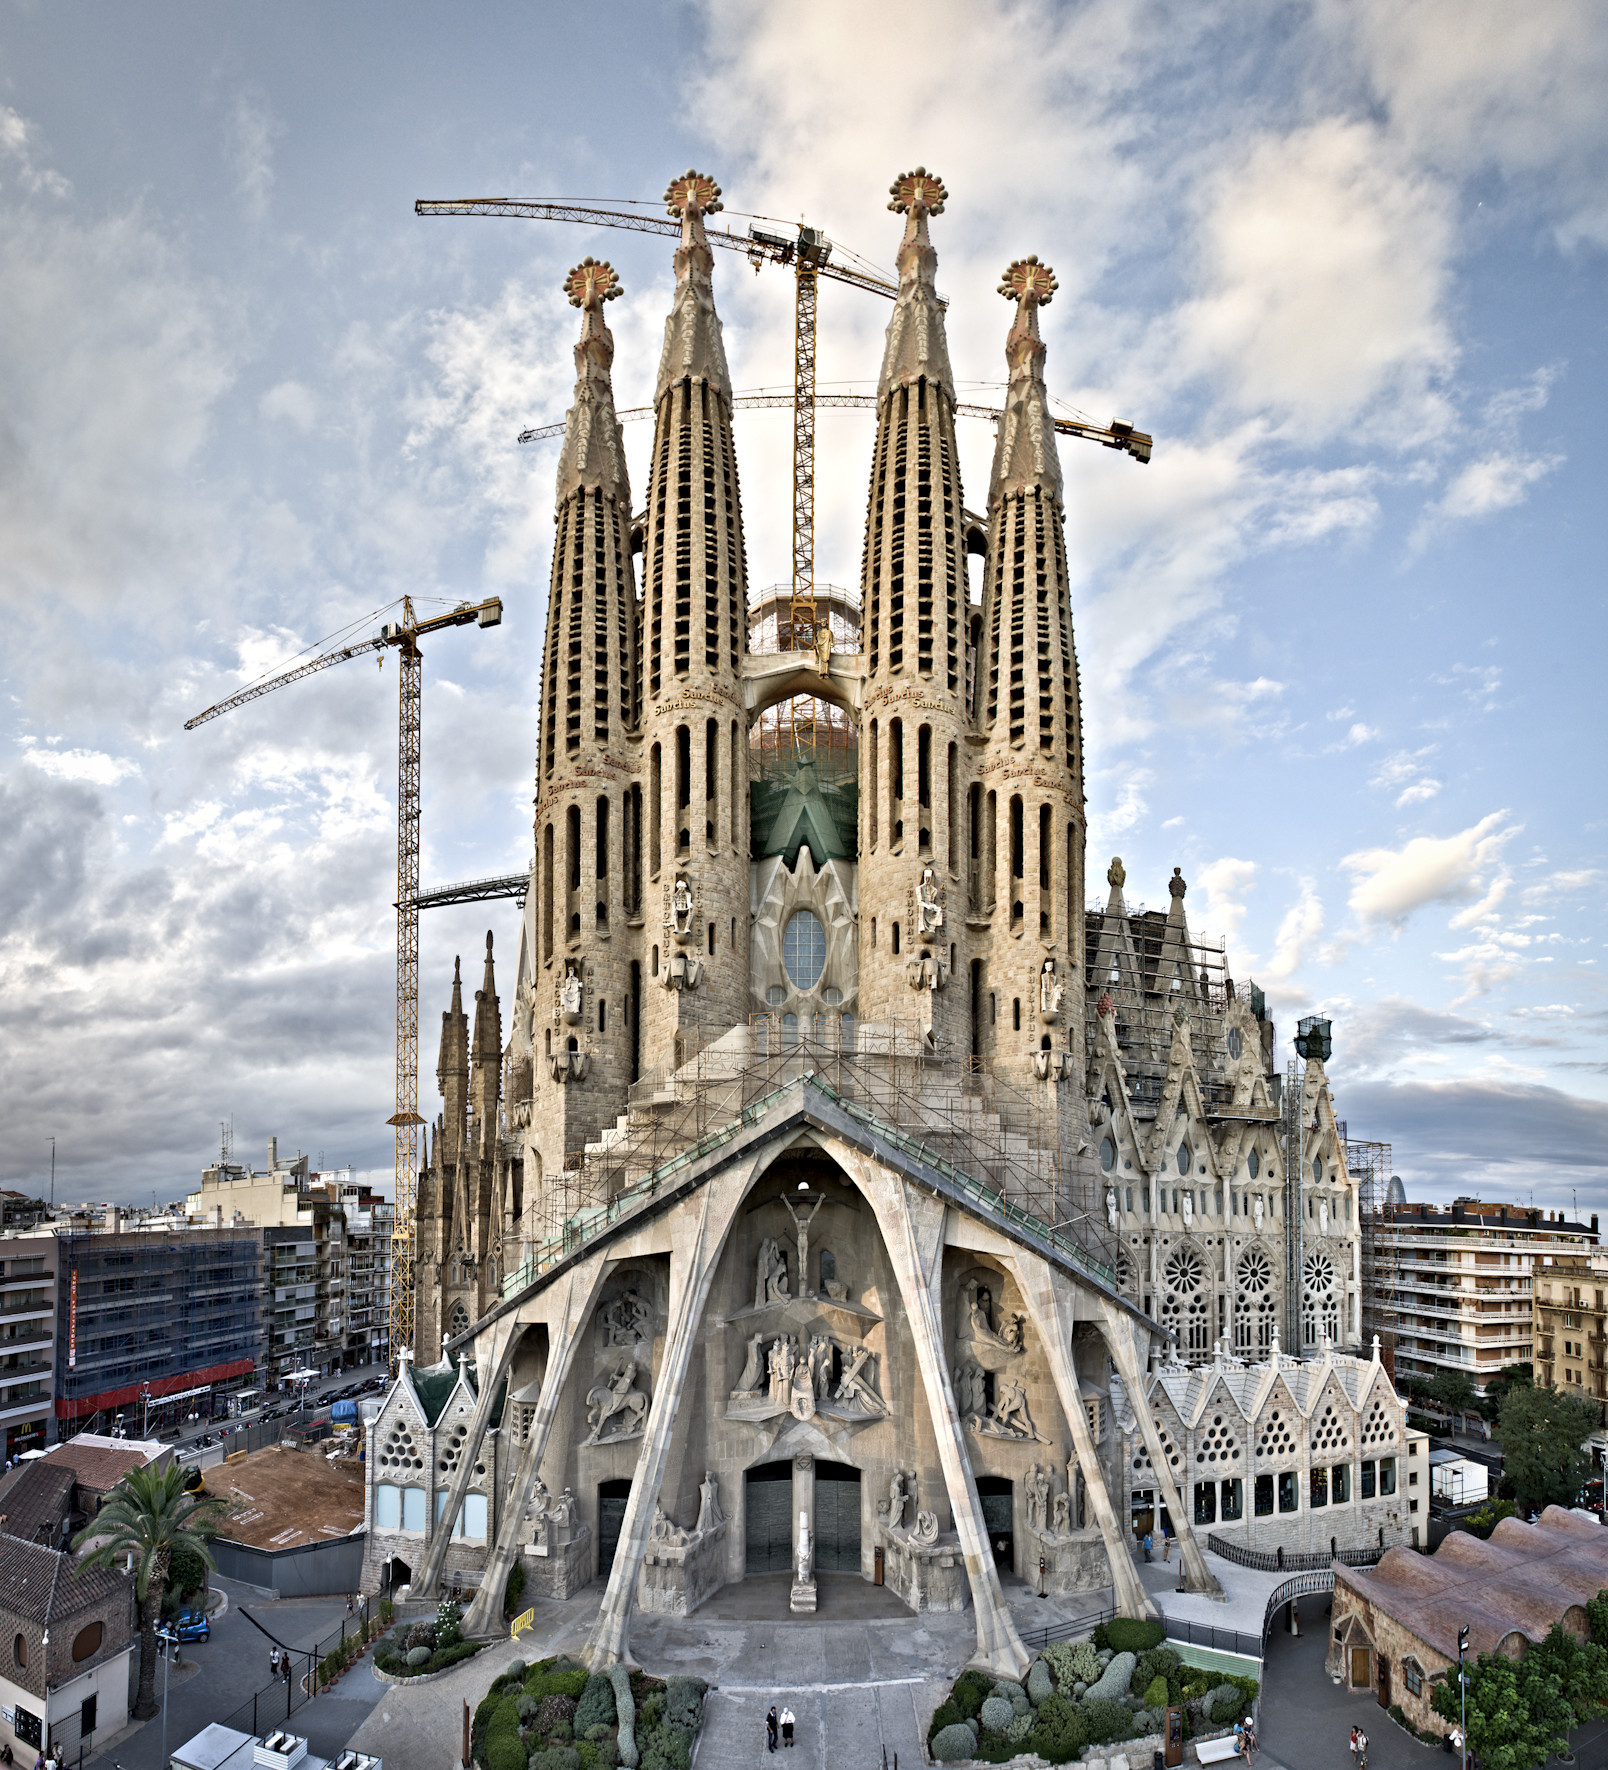What can you tell me about the historical significance of this structure? The Sagrada Familia is not just an architectural marvel; it is also a symbol of Barcelona's rich cultural and religious heritage. Designed by the renowned architect Antoni Gaudí, its construction began in 1882 and continues to this day, making it one of the longest ongoing architectural projects in the world.

The basilica embodies the Catalan Modernisme style, with its innovative design and organic forms inspired by nature. Gaudí's approach combined artistic and engineering prowess, resulting in a structure that transcends mere functionality to become a work of art. The Sagrada Familia's historical significance is also marked by its designation as a UNESCO World Heritage Site, highlighting its importance to global cultural heritage. 